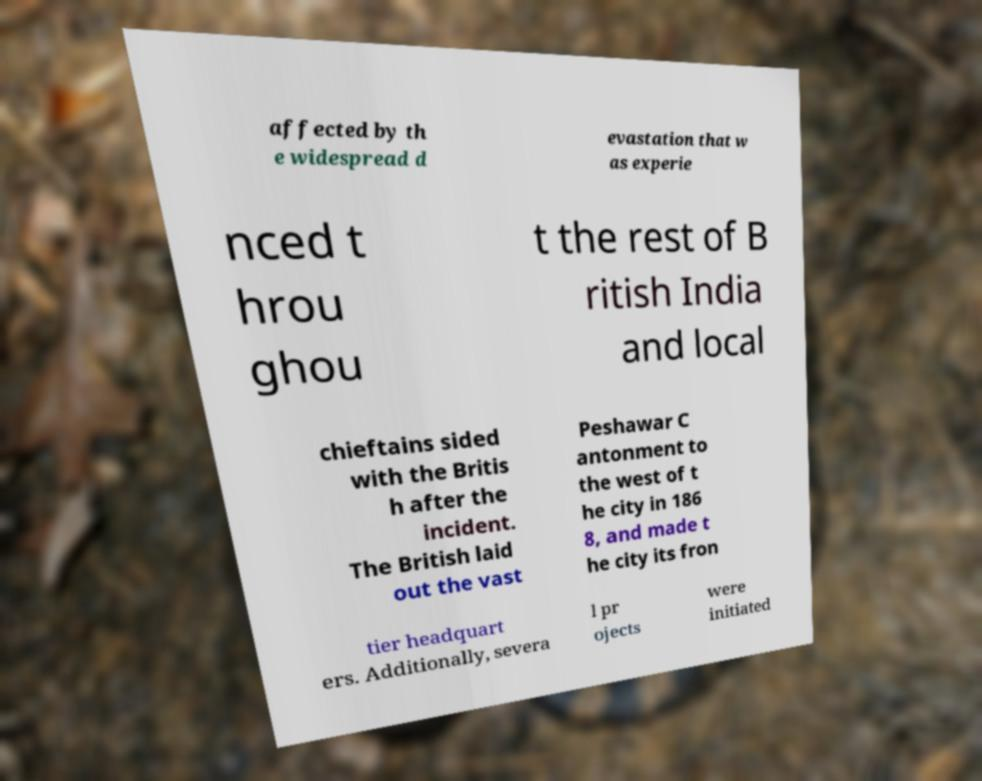I need the written content from this picture converted into text. Can you do that? affected by th e widespread d evastation that w as experie nced t hrou ghou t the rest of B ritish India and local chieftains sided with the Britis h after the incident. The British laid out the vast Peshawar C antonment to the west of t he city in 186 8, and made t he city its fron tier headquart ers. Additionally, severa l pr ojects were initiated 